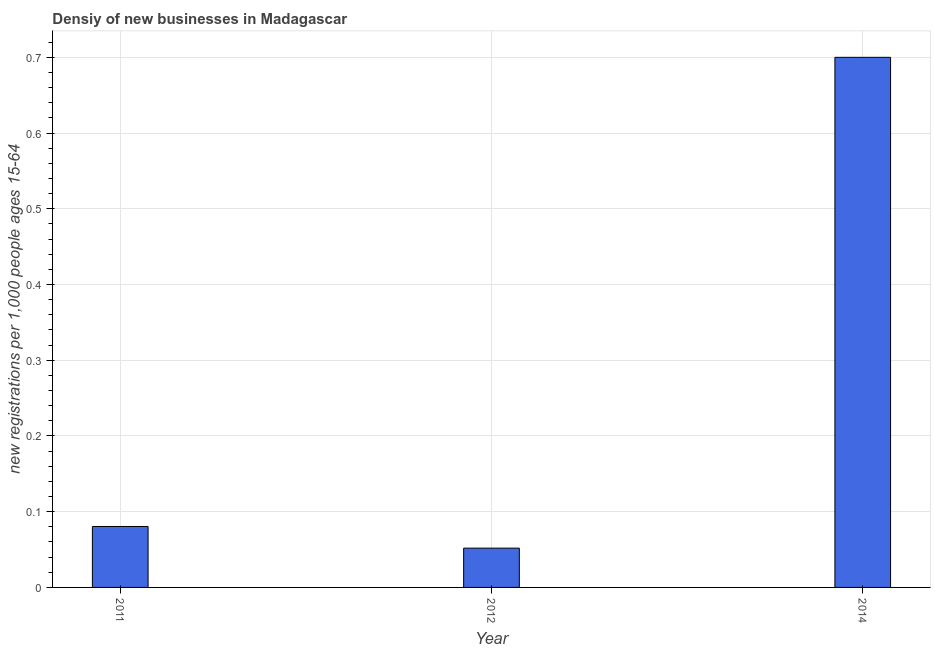Does the graph contain any zero values?
Offer a very short reply. No. Does the graph contain grids?
Your answer should be very brief. Yes. What is the title of the graph?
Make the answer very short. Densiy of new businesses in Madagascar. What is the label or title of the Y-axis?
Offer a very short reply. New registrations per 1,0 people ages 15-64. What is the density of new business in 2014?
Your answer should be compact. 0.7. Across all years, what is the maximum density of new business?
Give a very brief answer. 0.7. Across all years, what is the minimum density of new business?
Ensure brevity in your answer.  0.05. In which year was the density of new business maximum?
Make the answer very short. 2014. What is the sum of the density of new business?
Give a very brief answer. 0.83. What is the difference between the density of new business in 2012 and 2014?
Ensure brevity in your answer.  -0.65. What is the average density of new business per year?
Provide a succinct answer. 0.28. What is the median density of new business?
Keep it short and to the point. 0.08. In how many years, is the density of new business greater than 0.7 ?
Offer a very short reply. 0. What is the ratio of the density of new business in 2011 to that in 2012?
Offer a terse response. 1.55. Is the difference between the density of new business in 2012 and 2014 greater than the difference between any two years?
Offer a very short reply. Yes. What is the difference between the highest and the second highest density of new business?
Offer a very short reply. 0.62. Is the sum of the density of new business in 2012 and 2014 greater than the maximum density of new business across all years?
Offer a very short reply. Yes. What is the difference between the highest and the lowest density of new business?
Keep it short and to the point. 0.65. In how many years, is the density of new business greater than the average density of new business taken over all years?
Offer a terse response. 1. How many bars are there?
Your response must be concise. 3. How many years are there in the graph?
Provide a succinct answer. 3. What is the new registrations per 1,000 people ages 15-64 of 2011?
Give a very brief answer. 0.08. What is the new registrations per 1,000 people ages 15-64 in 2012?
Give a very brief answer. 0.05. What is the difference between the new registrations per 1,000 people ages 15-64 in 2011 and 2012?
Make the answer very short. 0.03. What is the difference between the new registrations per 1,000 people ages 15-64 in 2011 and 2014?
Provide a succinct answer. -0.62. What is the difference between the new registrations per 1,000 people ages 15-64 in 2012 and 2014?
Offer a terse response. -0.65. What is the ratio of the new registrations per 1,000 people ages 15-64 in 2011 to that in 2012?
Offer a very short reply. 1.55. What is the ratio of the new registrations per 1,000 people ages 15-64 in 2011 to that in 2014?
Your response must be concise. 0.12. What is the ratio of the new registrations per 1,000 people ages 15-64 in 2012 to that in 2014?
Offer a very short reply. 0.07. 